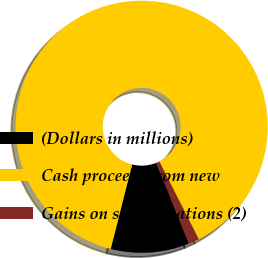Convert chart to OTSL. <chart><loc_0><loc_0><loc_500><loc_500><pie_chart><fcel>(Dollars in millions)<fcel>Cash proceeds from new<fcel>Gains on securitizations (2)<nl><fcel>10.08%<fcel>88.57%<fcel>1.35%<nl></chart> 